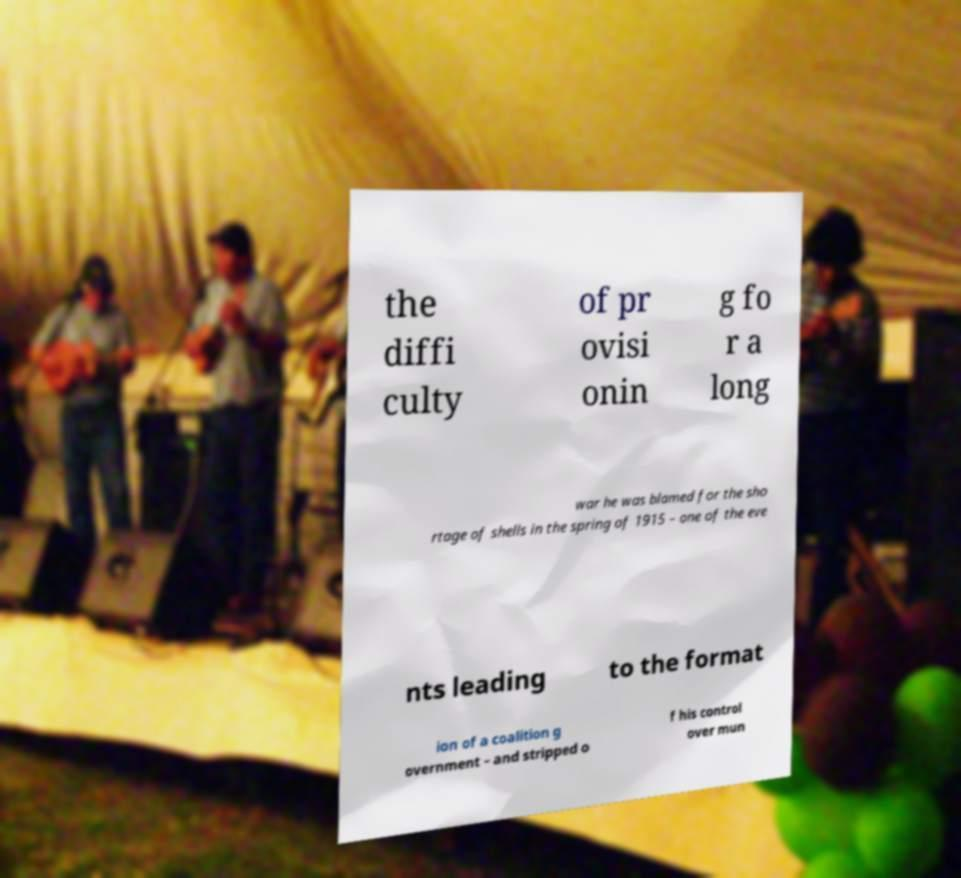Could you extract and type out the text from this image? the diffi culty of pr ovisi onin g fo r a long war he was blamed for the sho rtage of shells in the spring of 1915 – one of the eve nts leading to the format ion of a coalition g overnment – and stripped o f his control over mun 